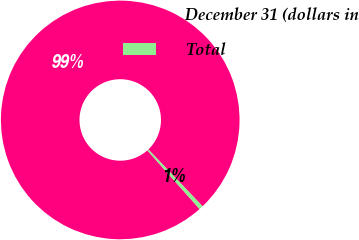Convert chart. <chart><loc_0><loc_0><loc_500><loc_500><pie_chart><fcel>December 31 (dollars in<fcel>Total<nl><fcel>99.46%<fcel>0.54%<nl></chart> 